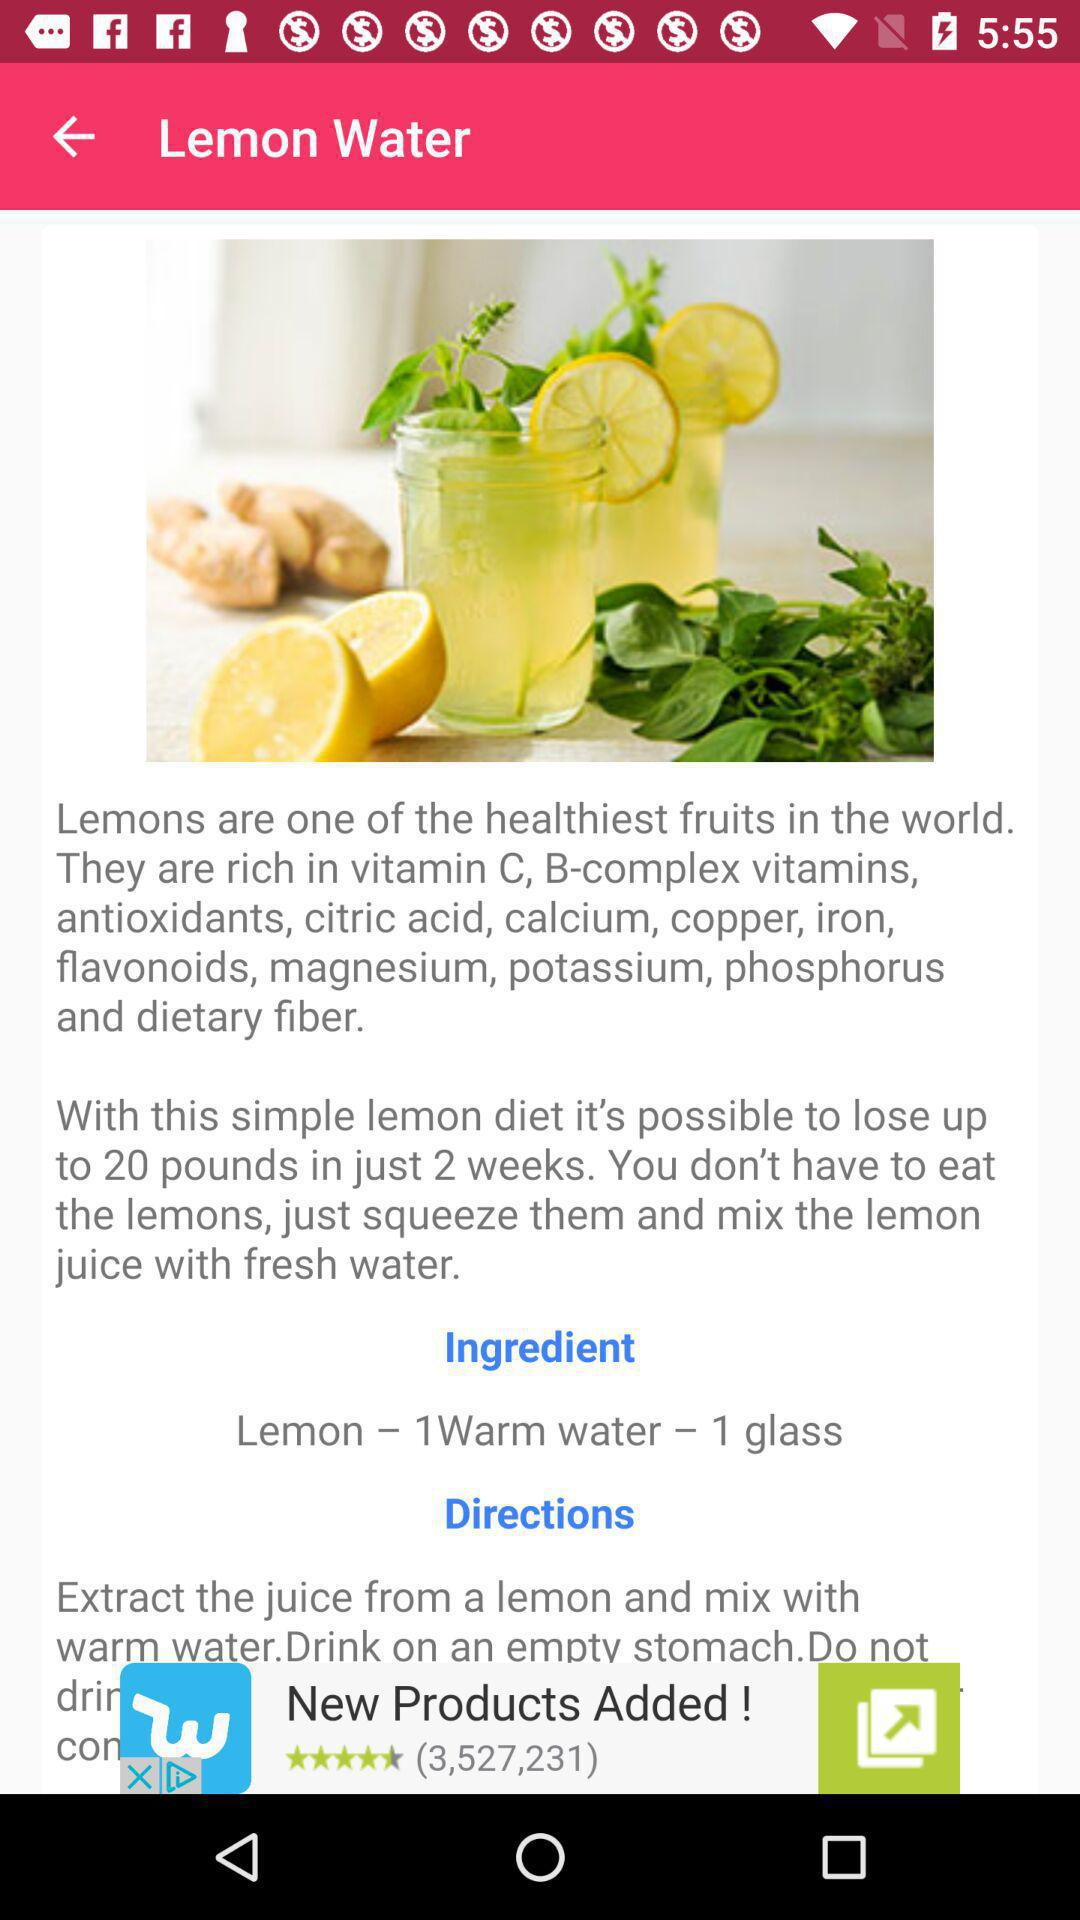How many ingredients are there for the lemon water recipe?
Answer the question using a single word or phrase. 2 